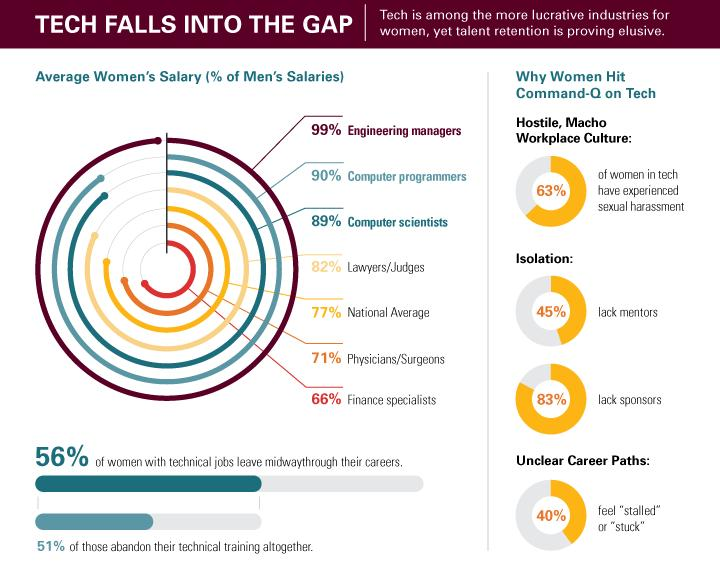Point out several critical features in this image. 60% of respondents reported that they do not feel stuck in their current job. According to the data, 55% of respondents reported having mentors. Approximately 17% of sponsors have been identified. According to the data, 44% of women with technical jobs have not left their positions midway through their careers. According to a recent survey, only 37% of women in the tech industry have not experienced sexual harassment. 